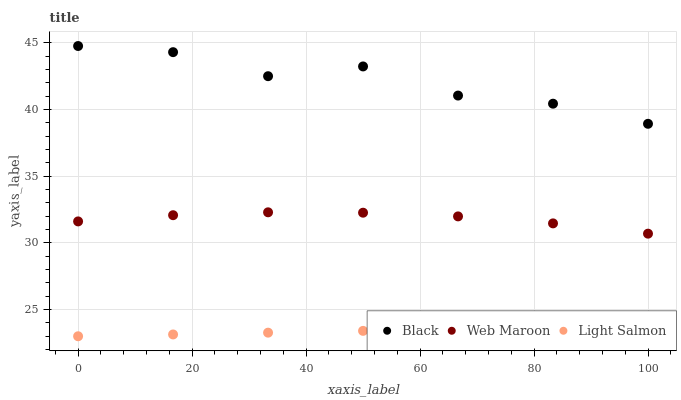Does Light Salmon have the minimum area under the curve?
Answer yes or no. Yes. Does Black have the maximum area under the curve?
Answer yes or no. Yes. Does Black have the minimum area under the curve?
Answer yes or no. No. Does Light Salmon have the maximum area under the curve?
Answer yes or no. No. Is Light Salmon the smoothest?
Answer yes or no. Yes. Is Black the roughest?
Answer yes or no. Yes. Is Black the smoothest?
Answer yes or no. No. Is Light Salmon the roughest?
Answer yes or no. No. Does Light Salmon have the lowest value?
Answer yes or no. Yes. Does Black have the lowest value?
Answer yes or no. No. Does Black have the highest value?
Answer yes or no. Yes. Does Light Salmon have the highest value?
Answer yes or no. No. Is Light Salmon less than Web Maroon?
Answer yes or no. Yes. Is Black greater than Web Maroon?
Answer yes or no. Yes. Does Light Salmon intersect Web Maroon?
Answer yes or no. No. 